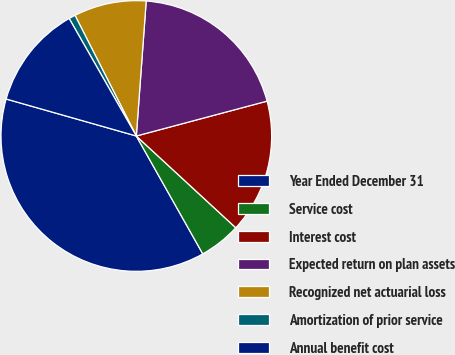<chart> <loc_0><loc_0><loc_500><loc_500><pie_chart><fcel>Year Ended December 31<fcel>Service cost<fcel>Interest cost<fcel>Expected return on plan assets<fcel>Recognized net actuarial loss<fcel>Amortization of prior service<fcel>Annual benefit cost<nl><fcel>37.58%<fcel>4.97%<fcel>16.01%<fcel>19.69%<fcel>8.65%<fcel>0.78%<fcel>12.33%<nl></chart> 